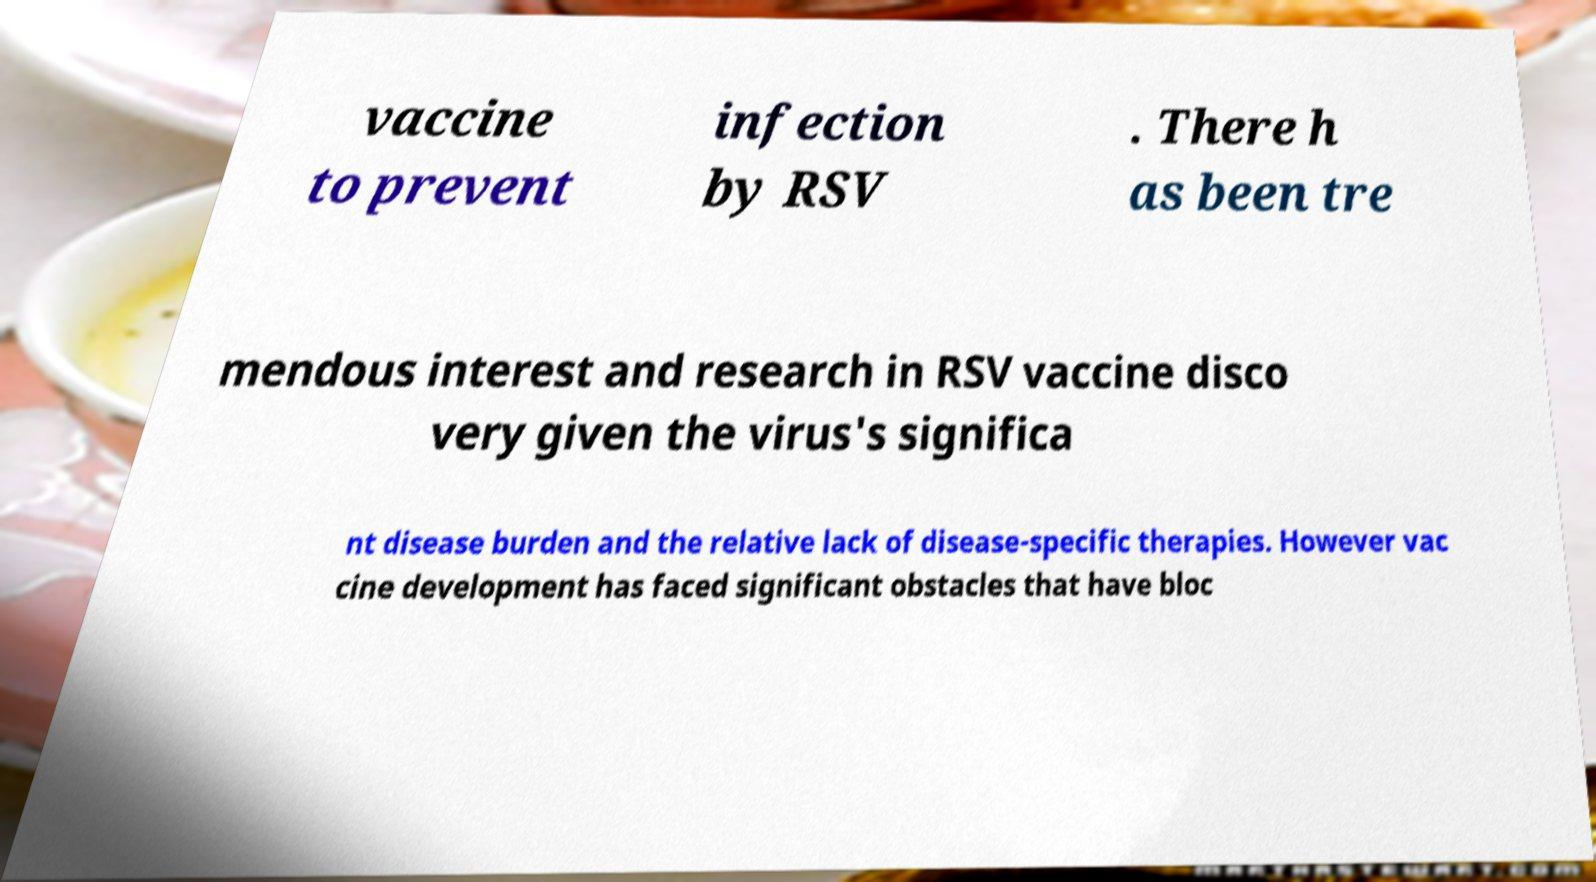Could you extract and type out the text from this image? vaccine to prevent infection by RSV . There h as been tre mendous interest and research in RSV vaccine disco very given the virus's significa nt disease burden and the relative lack of disease-specific therapies. However vac cine development has faced significant obstacles that have bloc 